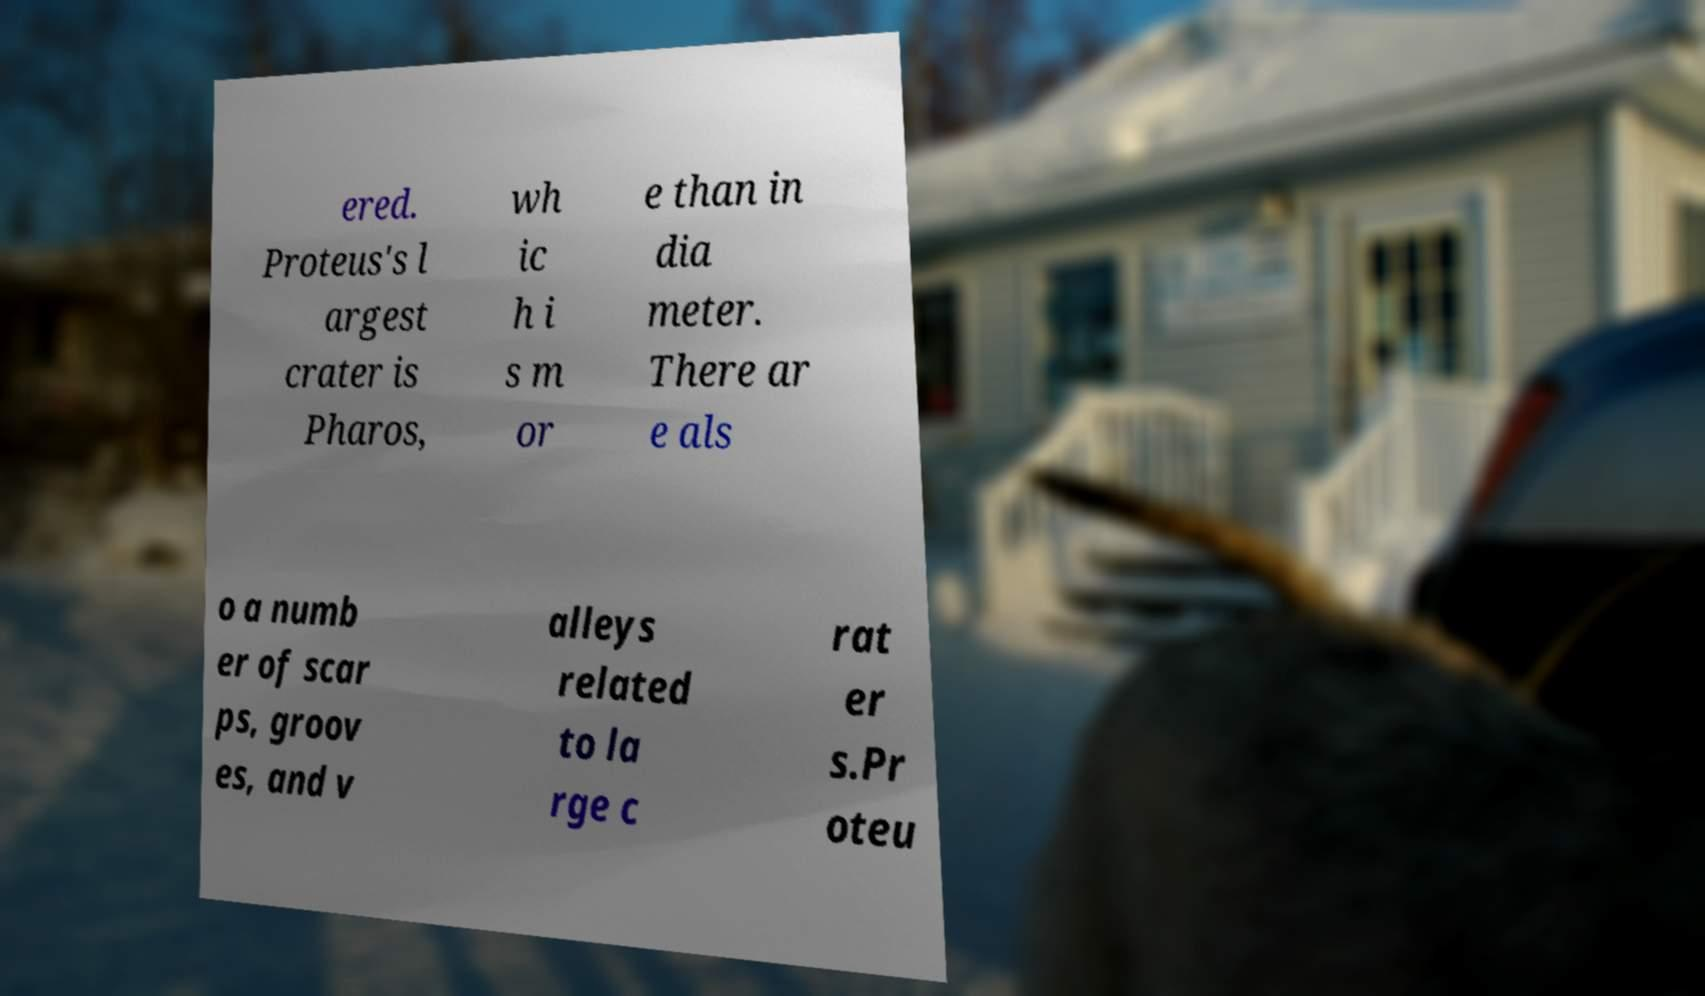What messages or text are displayed in this image? I need them in a readable, typed format. ered. Proteus's l argest crater is Pharos, wh ic h i s m or e than in dia meter. There ar e als o a numb er of scar ps, groov es, and v alleys related to la rge c rat er s.Pr oteu 